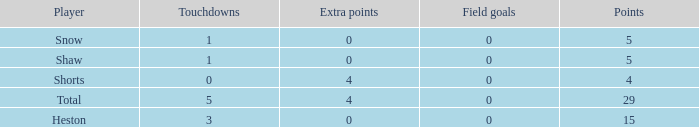What is the total number of field goals a player had when there were more than 0 extra points and there were 5 touchdowns? 1.0. 